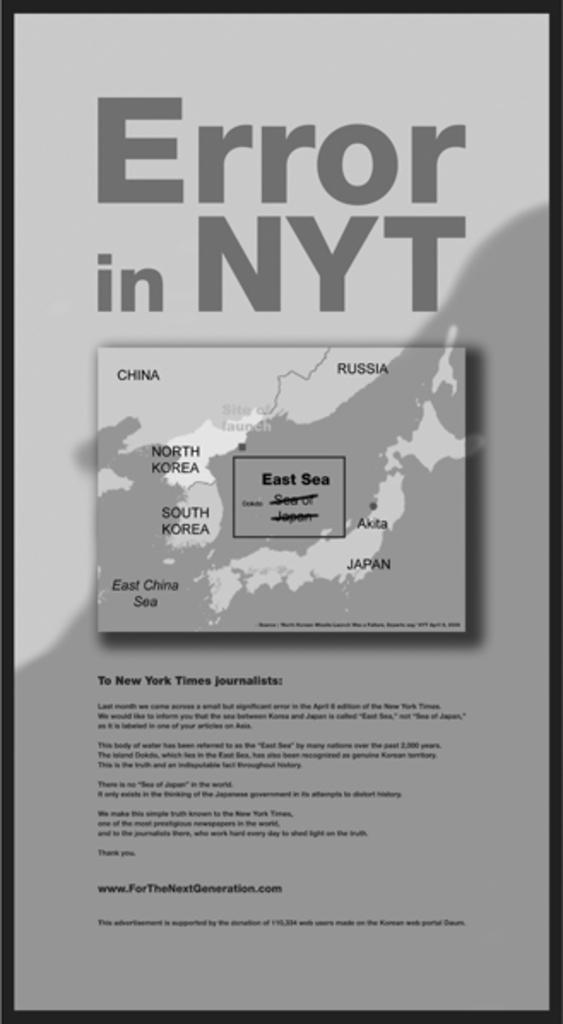What is the main subject of the image? There is an object in the image. What can be found on the object? Text is written on the object, and there is a map on it. Where is the goat located in the image? There is no goat present in the image. What type of alley can be seen in the image? There is no alley present in the image. 